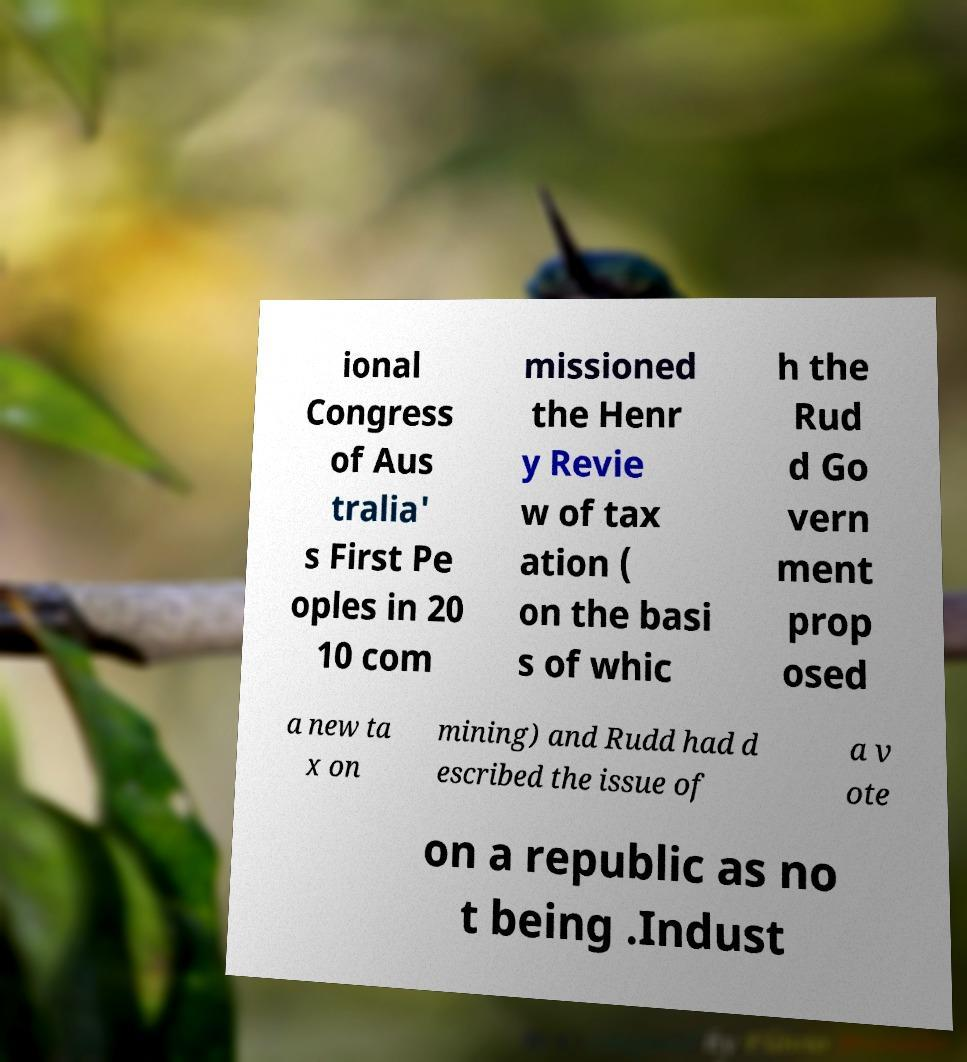Can you read and provide the text displayed in the image?This photo seems to have some interesting text. Can you extract and type it out for me? ional Congress of Aus tralia' s First Pe oples in 20 10 com missioned the Henr y Revie w of tax ation ( on the basi s of whic h the Rud d Go vern ment prop osed a new ta x on mining) and Rudd had d escribed the issue of a v ote on a republic as no t being .Indust 